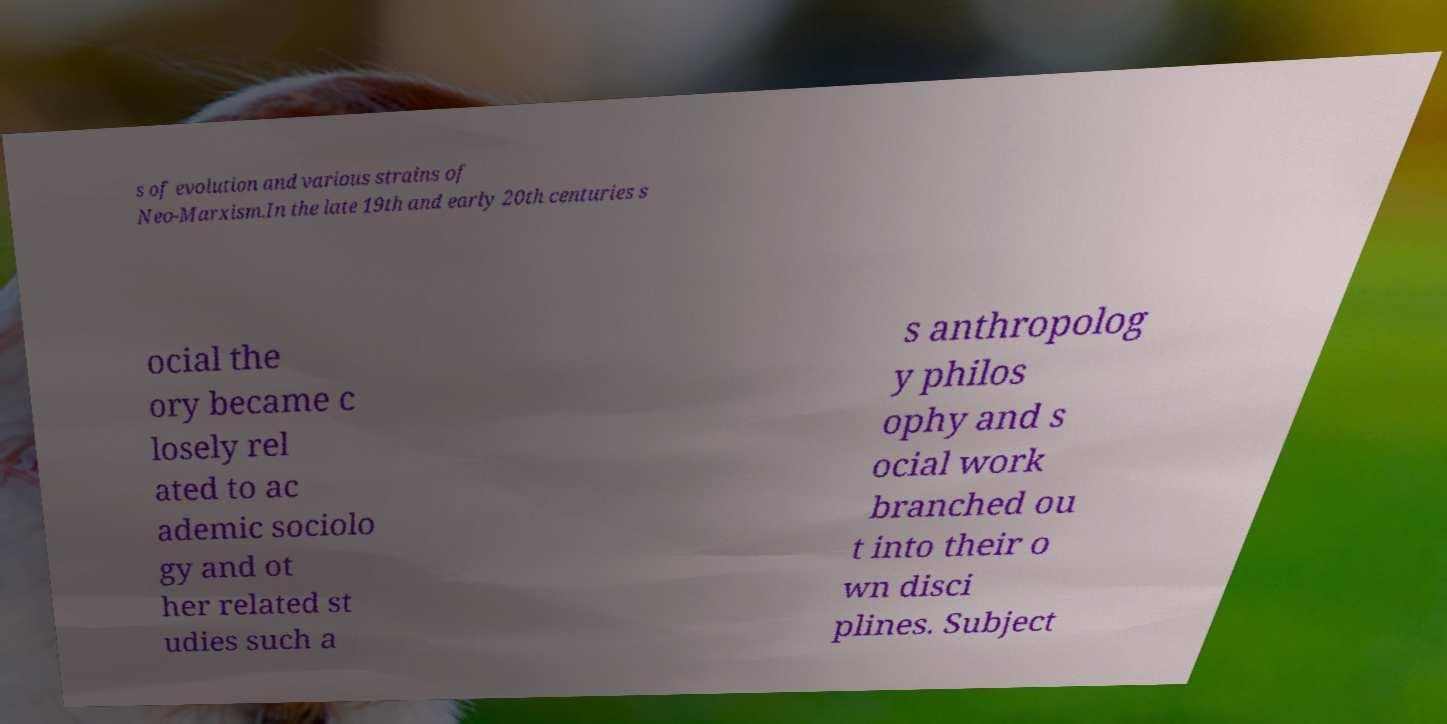For documentation purposes, I need the text within this image transcribed. Could you provide that? s of evolution and various strains of Neo-Marxism.In the late 19th and early 20th centuries s ocial the ory became c losely rel ated to ac ademic sociolo gy and ot her related st udies such a s anthropolog y philos ophy and s ocial work branched ou t into their o wn disci plines. Subject 